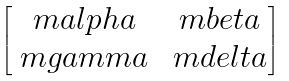Convert formula to latex. <formula><loc_0><loc_0><loc_500><loc_500>\begin{bmatrix} \ m a l p h a & \ m b e t a \\ \ m g a m m a & \ m d e l t a \end{bmatrix}</formula> 